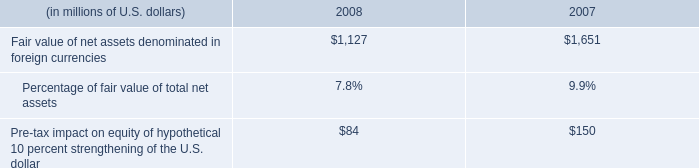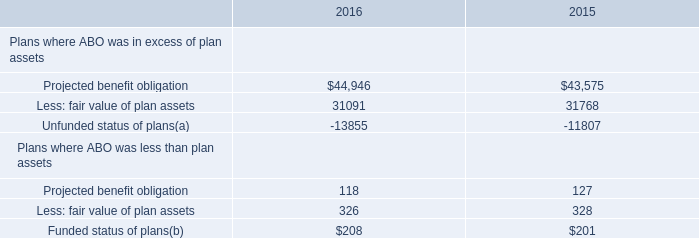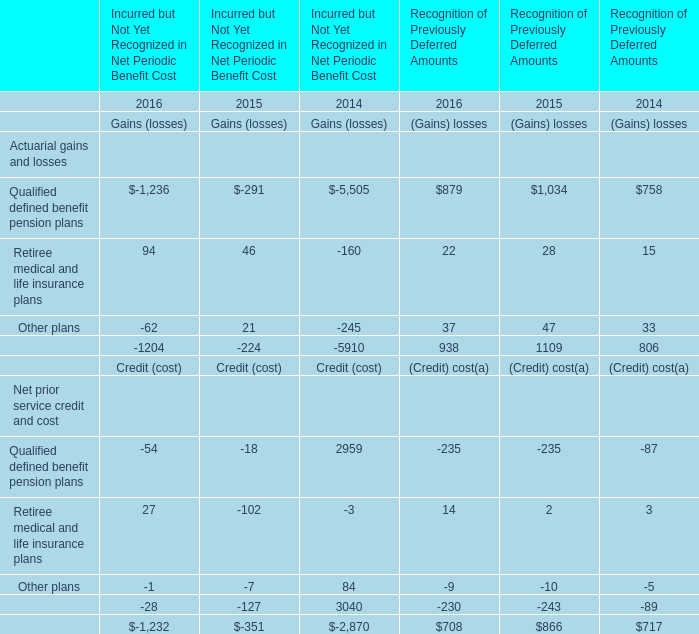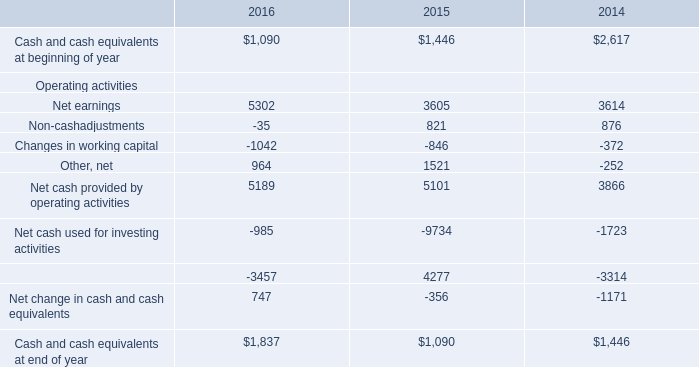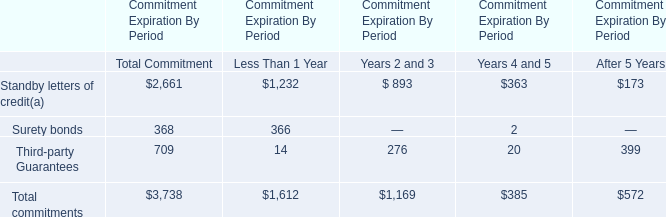what's the total amount of Projected benefit obligation of 2016, and Net earnings Operating activities of 2015 ? 
Computations: (44946.0 + 3605.0)
Answer: 48551.0. 